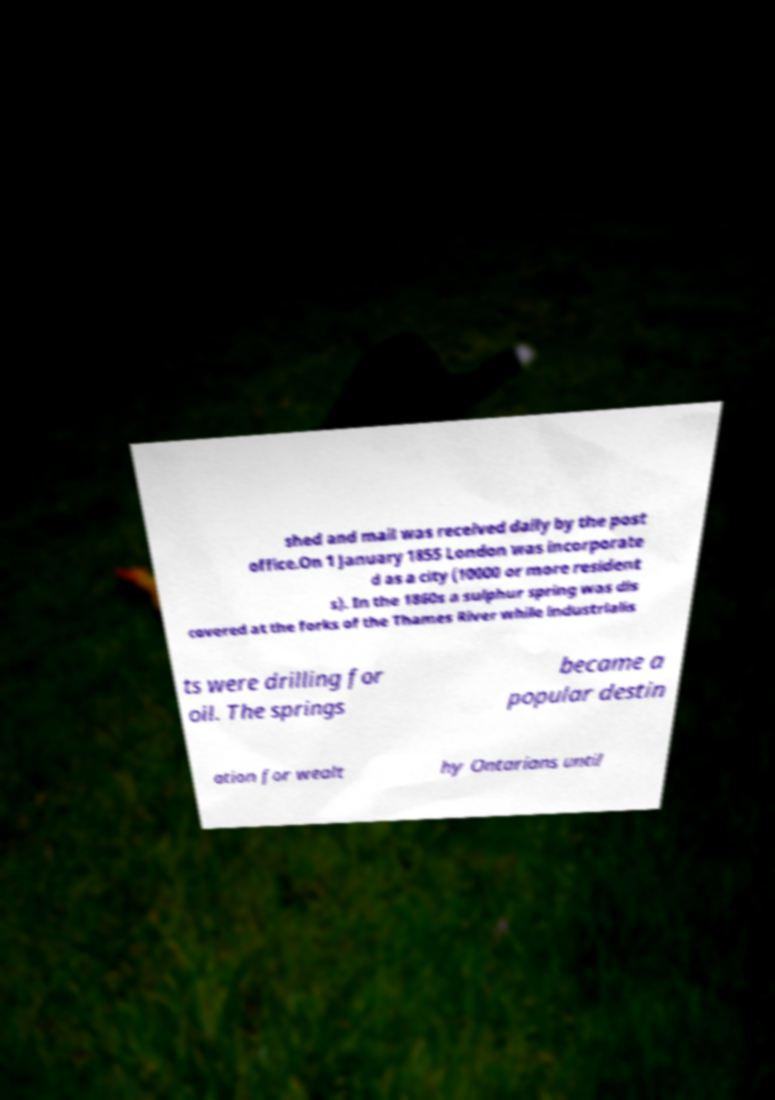There's text embedded in this image that I need extracted. Can you transcribe it verbatim? shed and mail was received daily by the post office.On 1 January 1855 London was incorporate d as a city (10000 or more resident s). In the 1860s a sulphur spring was dis covered at the forks of the Thames River while industrialis ts were drilling for oil. The springs became a popular destin ation for wealt hy Ontarians until 